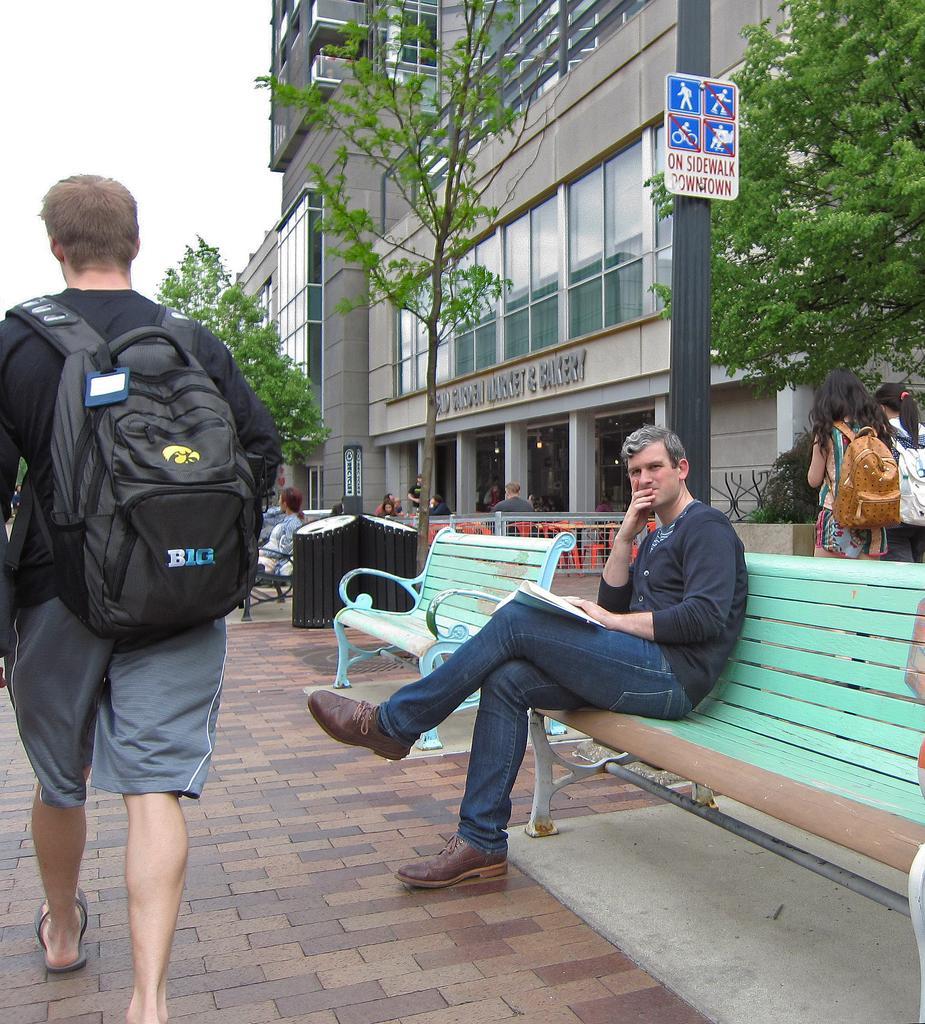How would you summarize this image in a sentence or two? In this image i can see a man sitting and the other man standing wearing bag and walking on the path way the man sitting is wearing a black t-shirt and a jeans and sitting on a green bench, there is the other bench beside him, at the back ground i can see a black bin, a tree, a building, a window, a board attached to a pole and sky, and there are other two women wearing bag and walking at right, in front there is another woman sitting on the bench. 